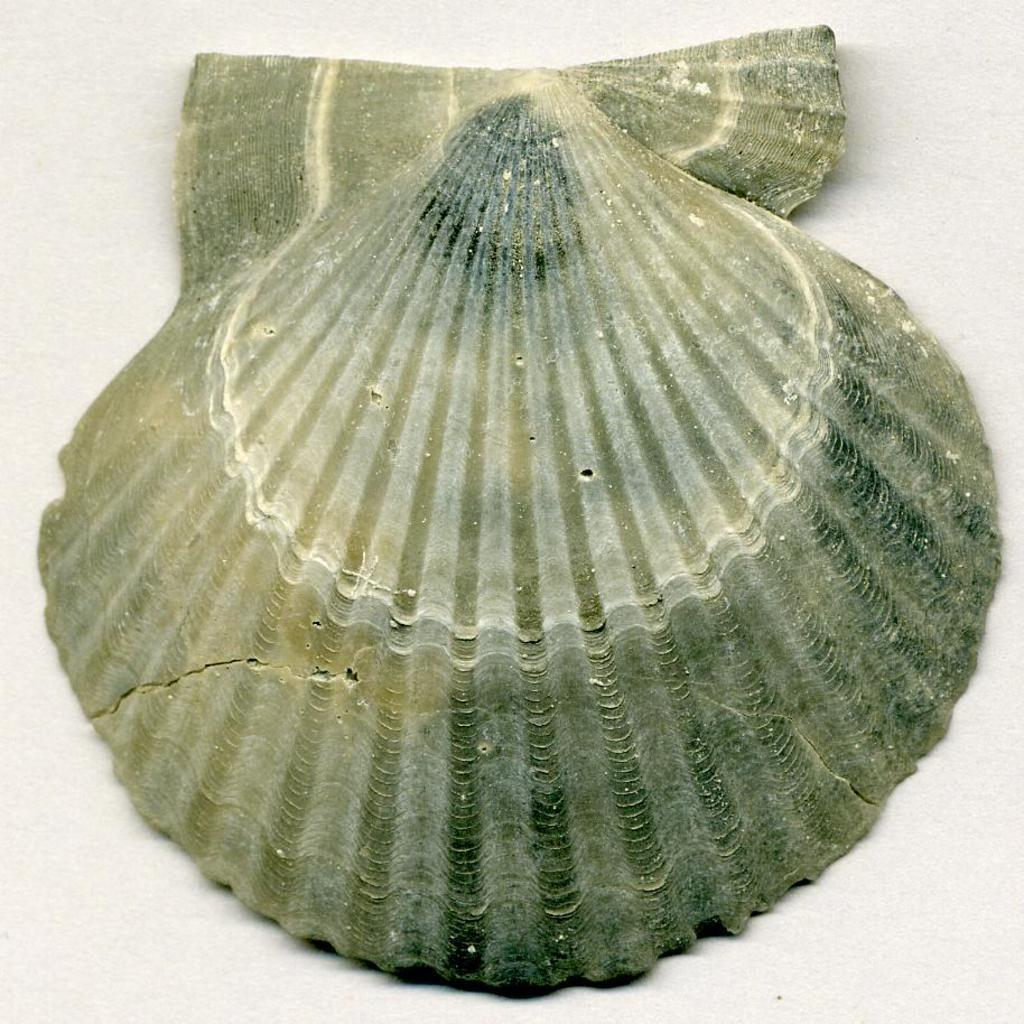What is the main subject in the center of the image? There is an object in the center of the image. What can be said about the color of the object? The object is green in color. What type of fang can be seen in the image? There is no fang present in the image; it only features an object that is green in color. What is the weather like in the image? The image does not provide any information about the weather, as it only shows an object that is green in color. 